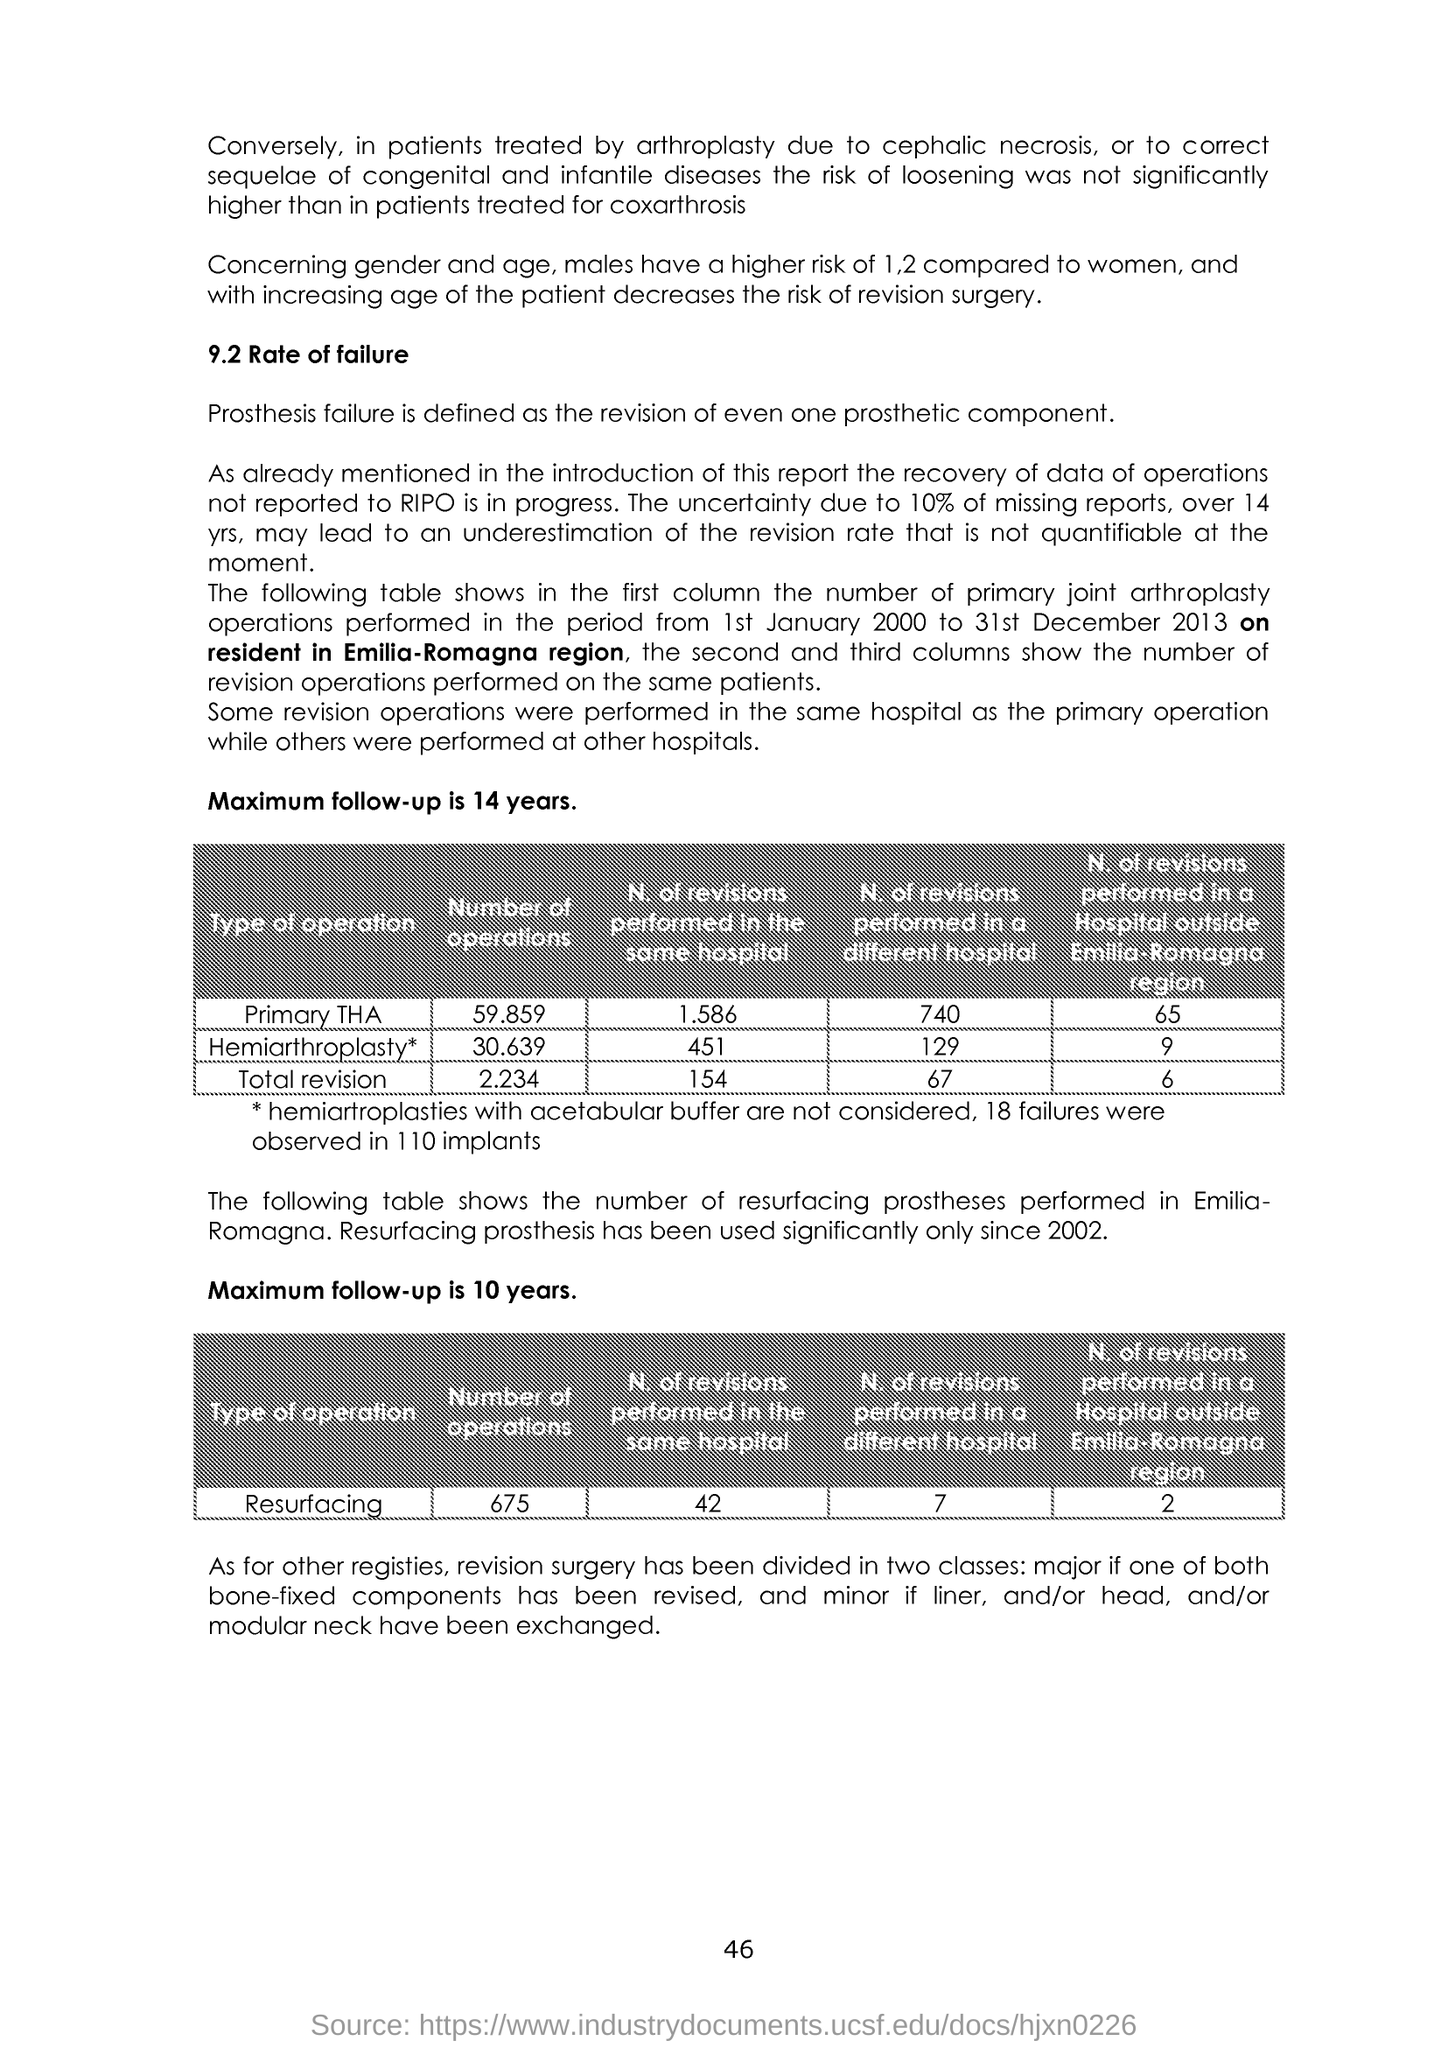Identify some key points in this picture. The page number is 46. 